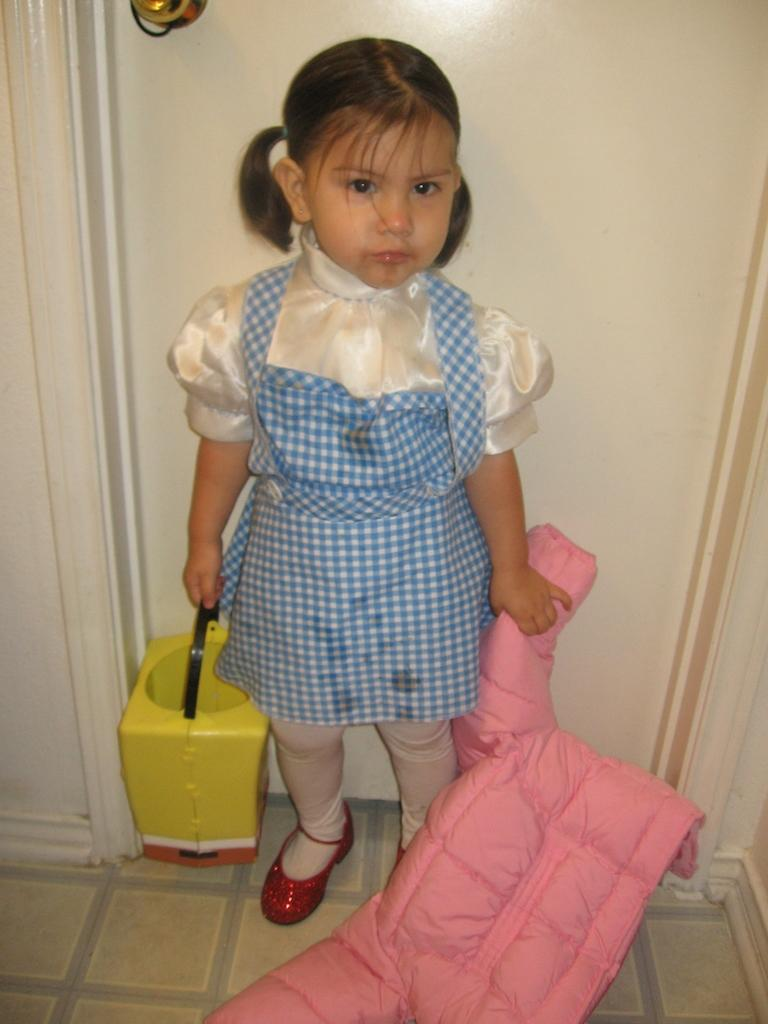What is the main subject of the image? The main subject of the image is a kid. What is the kid doing in the image? The kid is holding objects. What can be seen in the background of the image? There is a wall in the background of the image. Can you see a patch of wilderness in the image? There is no wilderness present in the image; it features a kid holding objects with a wall in the background. 